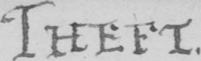Transcribe the text shown in this historical manuscript line. THEFT . 